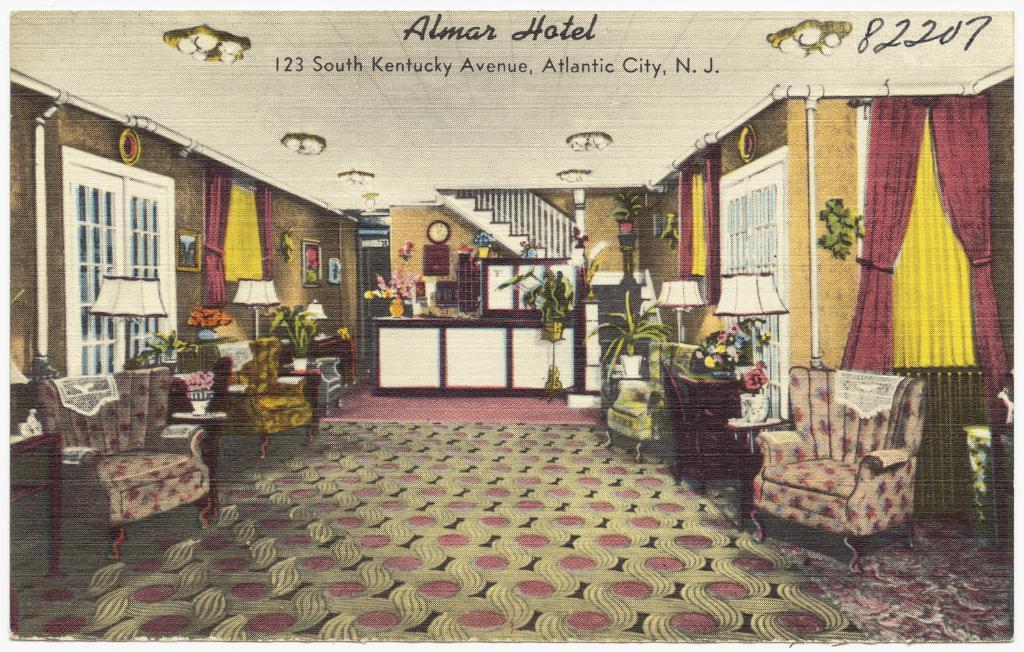In one or two sentences, can you explain what this image depicts? This image is an inside view of a hotel. In this image there are few couches, in between then there are lamps and plant pots. On the right and left side of the image there are windows, curtains and frames are hanging on the wall. In the background there is a table with a flower pot on it and there is a clock and few frames are hanging on the wall and there are stairs. At the top of the image there is a ceiling with lights. 